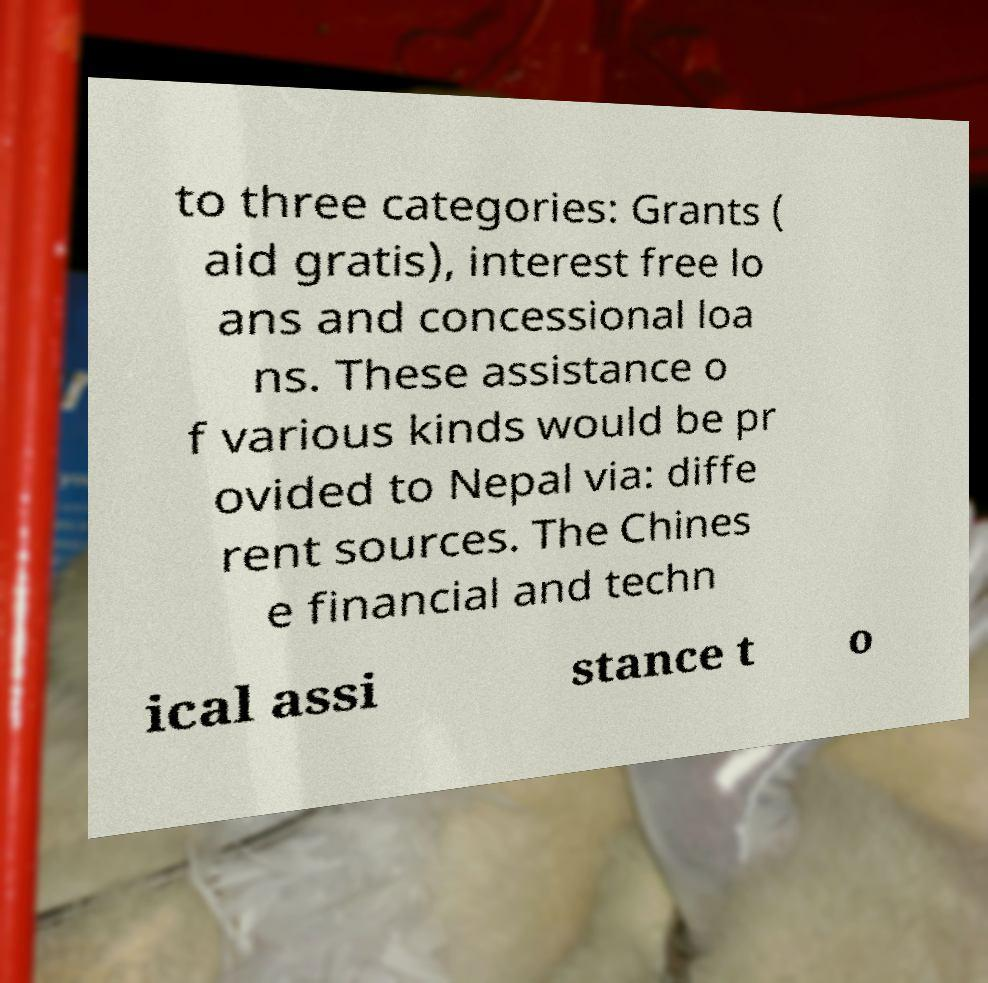For documentation purposes, I need the text within this image transcribed. Could you provide that? to three categories: Grants ( aid gratis), interest free lo ans and concessional loa ns. These assistance o f various kinds would be pr ovided to Nepal via: diffe rent sources. The Chines e financial and techn ical assi stance t o 